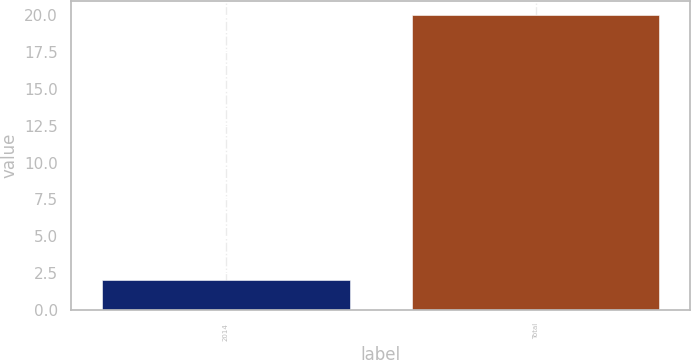Convert chart to OTSL. <chart><loc_0><loc_0><loc_500><loc_500><bar_chart><fcel>2014<fcel>Total<nl><fcel>2<fcel>20<nl></chart> 